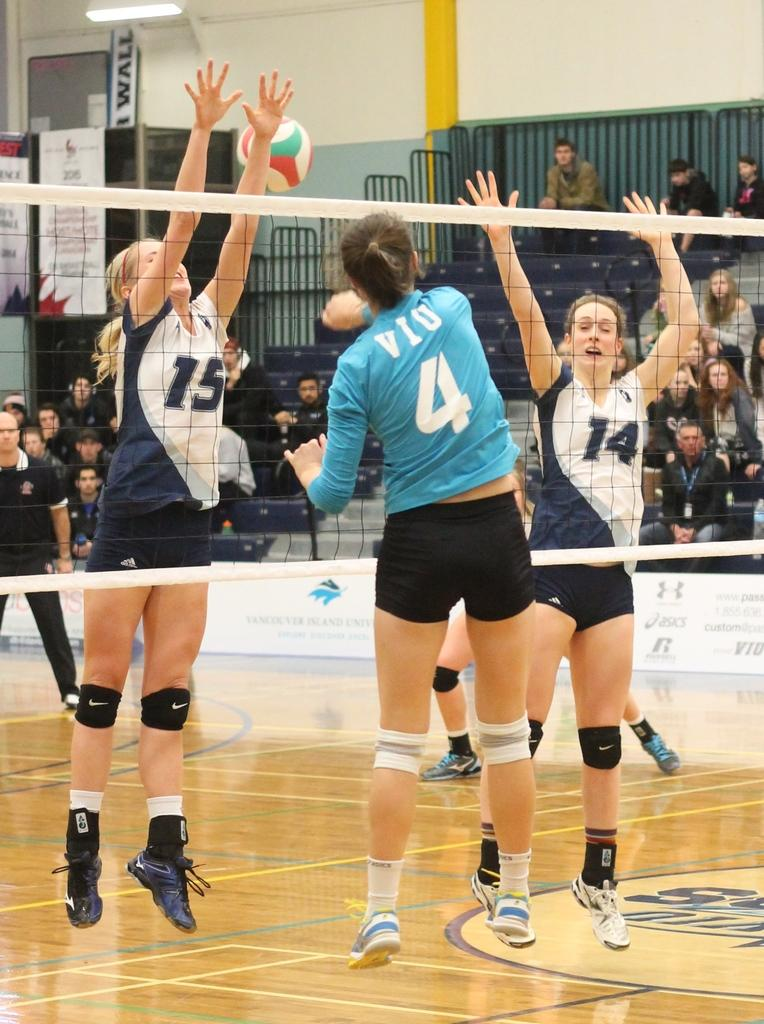Who or what can be seen in the image? There are people in the image. What object is associated with a sport in the image? There is a football in the image. What structure is present for catching or blocking the football? There is a net in the image. What additional element is present in the image? There is a banner in the image. What type of background can be seen in the image? There is a wall in the image. Where is the park located in the image? There is no park present in the image. What type of transportation can be seen at the airport in the image? There is no airport present in the image. 